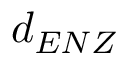<formula> <loc_0><loc_0><loc_500><loc_500>d _ { E N Z }</formula> 